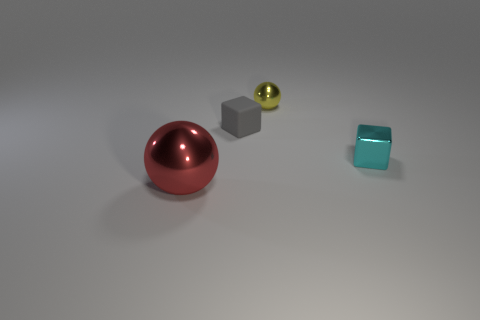Is the color of the ball that is right of the big sphere the same as the small matte thing?
Make the answer very short. No. How many things are either things in front of the gray rubber object or tiny cubes left of the small yellow thing?
Your answer should be very brief. 3. What number of metal things are to the left of the tiny cyan thing and right of the large red object?
Offer a terse response. 1. Are the yellow object and the red object made of the same material?
Provide a succinct answer. Yes. The shiny thing to the left of the tiny metallic thing that is to the left of the tiny block in front of the rubber block is what shape?
Offer a very short reply. Sphere. What material is the tiny thing that is in front of the small yellow ball and on the left side of the cyan metallic thing?
Your answer should be compact. Rubber. What is the color of the metallic ball behind the metal sphere that is on the left side of the sphere behind the cyan shiny cube?
Provide a short and direct response. Yellow. What number of purple objects are either small objects or big spheres?
Keep it short and to the point. 0. How many other objects are the same size as the gray matte thing?
Give a very brief answer. 2. What number of big gray balls are there?
Give a very brief answer. 0. 